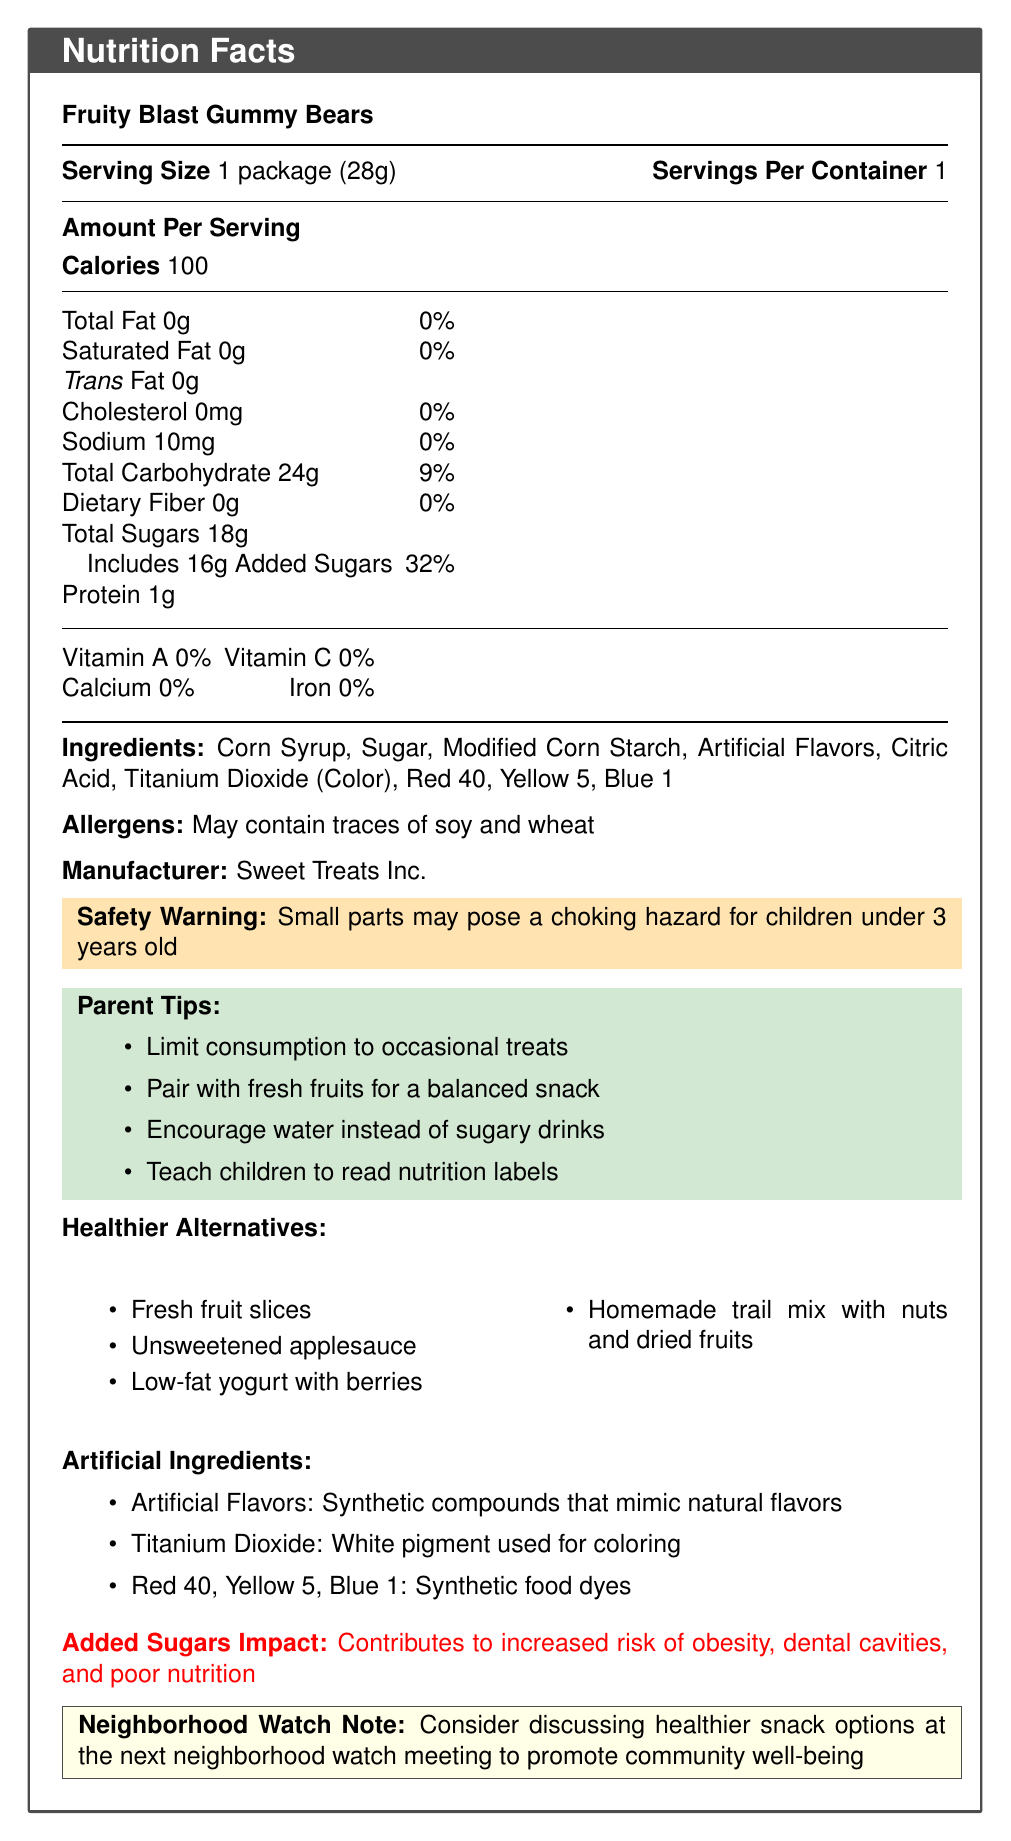what is the serving size of Fruity Blast Gummy Bears? The serving size is clearly mentioned in the document as "1 package (28g)".
Answer: 1 package (28g) how many calories are in one serving of Fruity Blast Gummy Bears? The document lists the calorie count as 100 per serving.
Answer: 100 what are the three artificial ingredients listed in Fruity Blast Gummy Bears? The document lists these components under ingredients and provides explanations for them.
Answer: Artificial Flavors, Titanium Dioxide, Red 40, Yellow 5, Blue 1 how much added sugar is in one serving of Fruity Blast Gummy Bears? The document states that 16g of the 18g total sugars are added sugars.
Answer: 16g what is the safety warning provided for Fruity Blast Gummy Bears? The safety warning is highlighted in the document noting that small parts may pose a choking hazard.
Answer: Small parts may pose a choking hazard for children under 3 years old which of the following is a healthier alternative to Fruity Blast Gummy Bears? A. Fresh fruit slices B. Candy bars C. Sweetened soda The document lists healthier alternatives including fresh fruit slices.
Answer: A. Fresh fruit slices how many grams of protein are in one serving? A. 0g B. 1g C. 5g D. 10g The document specifies that there is 1 gram of protein in one serving of the snack.
Answer: B. 1g which of the following vitamins and minerals are not present in Fruity Blast Gummy Bears? I. Vitamin A II. Vitamin C III. Calcium IV. Iron The document reports 0% of Vitamin A, Vitamin C, Calcium, and Iron in the product.
Answer: I, II, III, IV does Fruity Blast Gummy Bears contain soy and wheat allergens? The document specifies "May contain traces of soy and wheat" under the allergens section.
Answer: Yes what should parents do to ensure a balanced snack when giving Fruity Blast Gummy Bears to their children? One of the parent tips in the document is to "Pair with fresh fruits for a balanced snack."
Answer: Pair with fresh fruits explain the potential health impact of added sugars in Fruity Blast Gummy Bears. The document explains that added sugars contribute to these health risks.
Answer: Increased risk of obesity, dental cavities, and poor nutrition what company manufactures Fruity Blast Gummy Bears? The document mentions that the manufacturer is Sweet Treats Inc.
Answer: Sweet Treats Inc. is Titanium Dioxide a natural flavoring agent? The document describes Titanium Dioxide as a white pigment used for coloring, not as a flavoring agent.
Answer: No summarize the main idea of the Fruity Blast Gummy Bears nutrition facts document. The document is a comprehensive overview of Fruity Blast Gummy Bears, focusing on nutritional content, potential hazards, and recommendations for healthier snacking.
Answer: The document provides detailed nutritional information for Fruity Blast Gummy Bears, including serving size, calorie count, and ingredient list. It highlights high added sugar content and the presence of artificial ingredients. It also offers safety warnings, parent tips for healthier consumption, healthier snack alternatives, and discusses the impact of added sugars on health. is information about the product’s price provided in the document? There is no mention of the product's price in the provided document.
Answer: No 